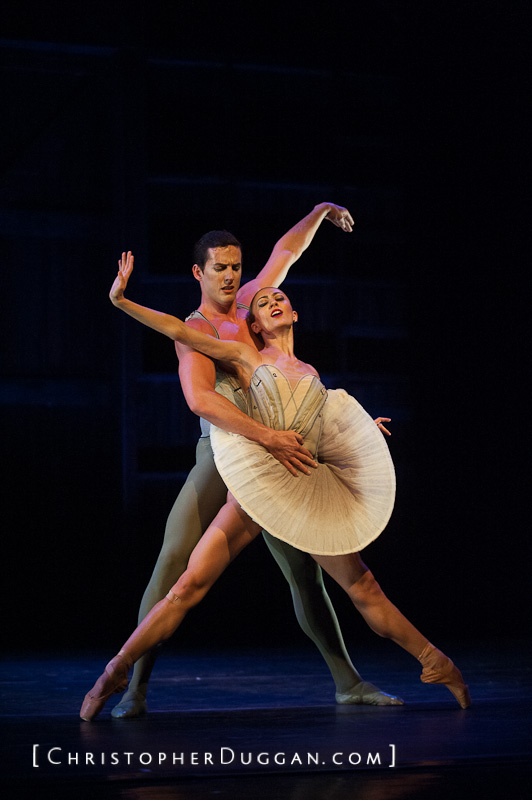Imagine the stage transforms into an otherworldly landscape as they dance. Describe this scene. As the dancers move gracefully, the stage around them begins to transform into an ethereal landscape. The floor shimmers and shifts, turning into a crystalline lake reflecting a sky full of swirling galaxies and constellations. Giant, luminescent flowers bloom at the edges of the stage, their petals glowing softly in hues of blue and violet. The background morphs into an enchanted forest, with trees whose branches are entwined with shimmering lights and tendrils of mist weaving through them. The dancers, now appearing like celestial beings, seem to glide effortlessly across the lake’s surface. Each of their movements sends ripples of light radiating outwards. As they reach out and intertwine, stars shoot across the sky above them, and the luminescent flowers sway, trailing sparkles in the air. This breathtaking, magical setting transforms their dance into a celestial ballet of otherworldly beauty and serenity. 